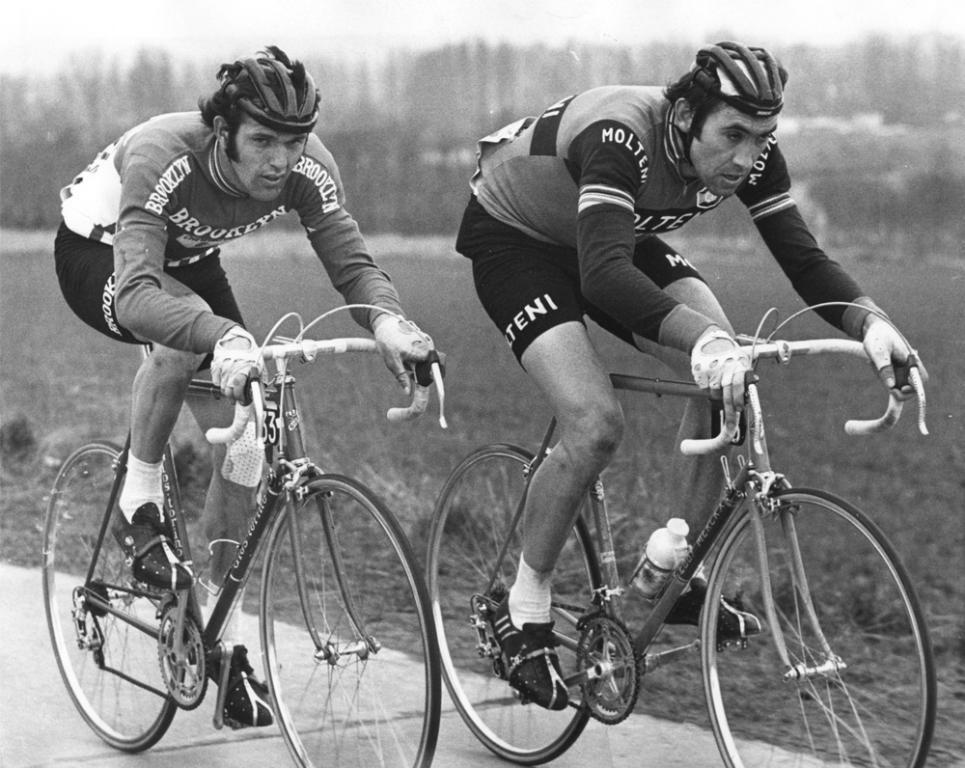What is the color scheme of the image? The image is black and white. How many people are in the image? There are two men in the image. What are the men doing in the image? The men are riding bicycles. What safety equipment are the men wearing? The men are wearing helmets. What type of environment can be seen in the image? There is grass and plants visible in the image. How would you describe the background of the image? The background is blurry. What time of day is it in the image, considering it is night? The image is not described as being at night, and there is no indication of the time of day. Additionally, the image is black and white, which makes it difficult to determine the time of day based on lighting. 